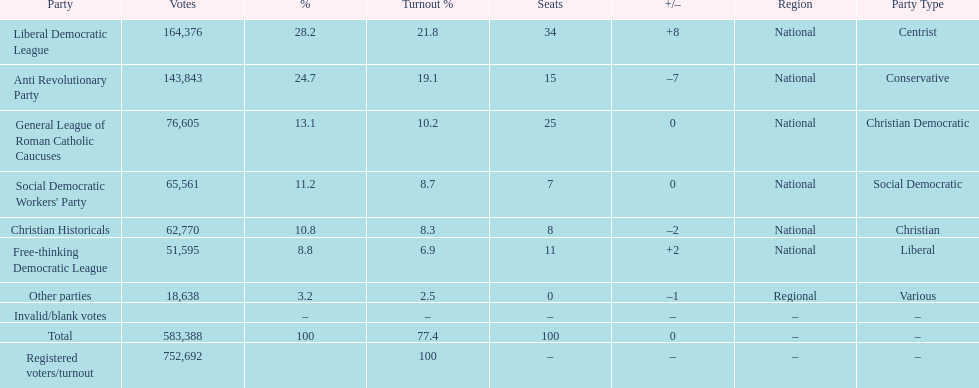After the election, how many seats did the liberal democratic league win? 34. 